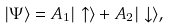<formula> <loc_0><loc_0><loc_500><loc_500>| \Psi \rangle = A _ { 1 } | \uparrow \rangle + A _ { 2 } | \downarrow \rangle ,</formula> 